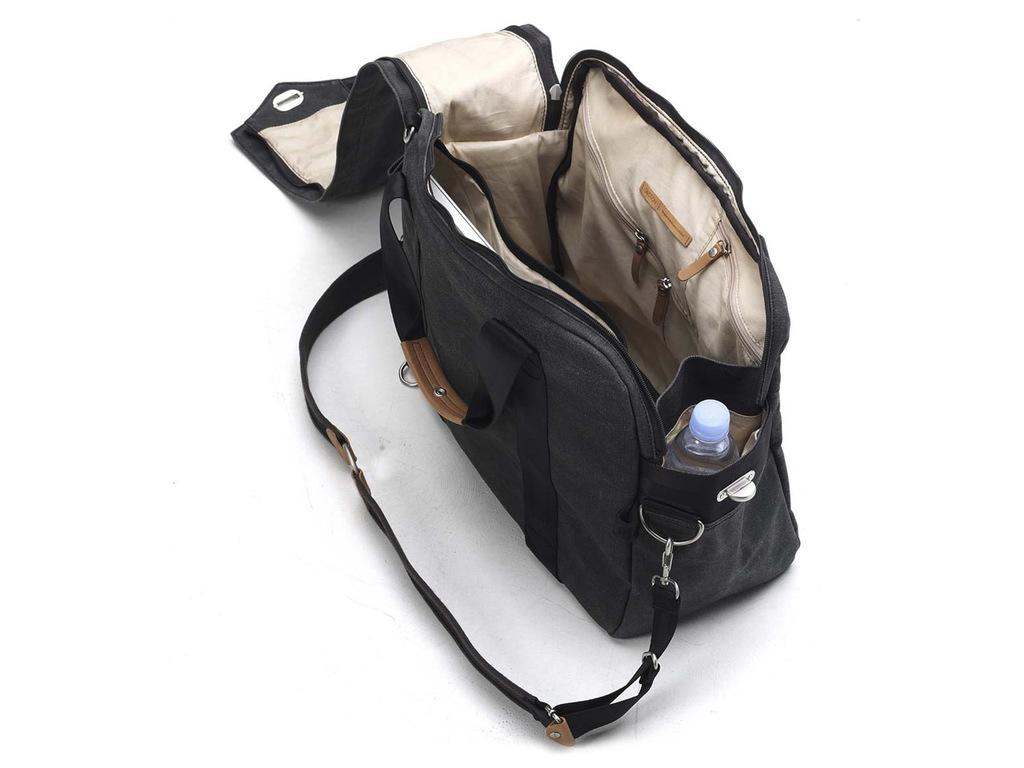What object is present in the image that can hold items? There is a bag in the image that can hold items. What feature does the bag have to secure it to the wearer? The bag has a belt. How can the bag be carried? The bag has straps for carrying. What is located on the right side of the bag? There is a bottle on the right side of the bag. On what surface is the bag placed? The bag is placed on a white color board. How many legs can be seen supporting the bag in the image? There are no legs visible in the image; the bag is placed on a white color board. What type of zipper is used on the bag in the image? There is no mention of a zipper on the bag in the provided facts, so it cannot be determined from the image. 